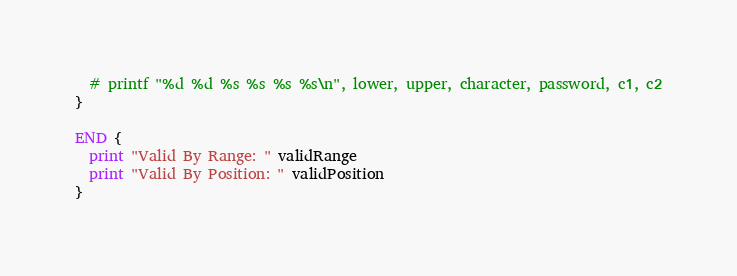Convert code to text. <code><loc_0><loc_0><loc_500><loc_500><_Awk_>  # printf "%d %d %s %s %s %s\n", lower, upper, character, password, c1, c2
}

END {
  print "Valid By Range: " validRange
  print "Valid By Position: " validPosition
}
</code> 